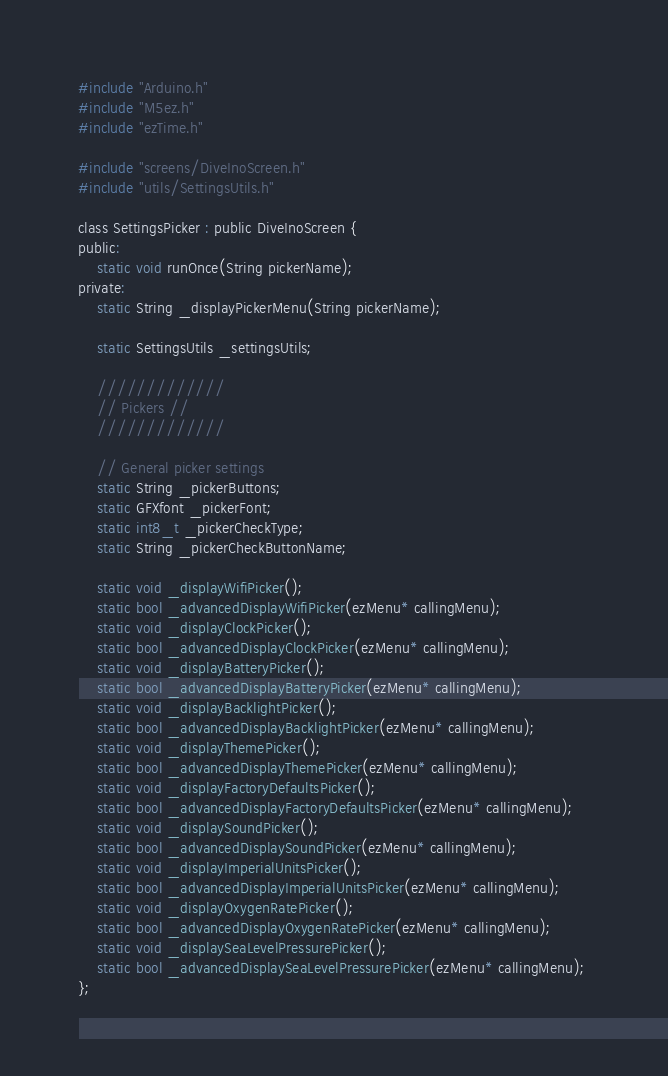<code> <loc_0><loc_0><loc_500><loc_500><_C_>#include "Arduino.h"
#include "M5ez.h"
#include "ezTime.h"

#include "screens/DiveInoScreen.h"
#include "utils/SettingsUtils.h"

class SettingsPicker : public DiveInoScreen {
public:    
    static void runOnce(String pickerName);        
private:
    static String _displayPickerMenu(String pickerName);

    static SettingsUtils _settingsUtils;

    /////////////
    // Pickers //
    /////////////

    // General picker settings
    static String _pickerButtons;
    static GFXfont _pickerFont;
    static int8_t _pickerCheckType;
    static String _pickerCheckButtonName;

    static void _displayWifiPicker();
    static bool _advancedDisplayWifiPicker(ezMenu* callingMenu);    
    static void _displayClockPicker();
    static bool _advancedDisplayClockPicker(ezMenu* callingMenu);
    static void _displayBatteryPicker();
    static bool _advancedDisplayBatteryPicker(ezMenu* callingMenu);    
    static void _displayBacklightPicker();
    static bool _advancedDisplayBacklightPicker(ezMenu* callingMenu);
    static void _displayThemePicker();
    static bool _advancedDisplayThemePicker(ezMenu* callingMenu);
    static void _displayFactoryDefaultsPicker();
    static bool _advancedDisplayFactoryDefaultsPicker(ezMenu* callingMenu);
    static void _displaySoundPicker();
    static bool _advancedDisplaySoundPicker(ezMenu* callingMenu);
    static void _displayImperialUnitsPicker();
    static bool _advancedDisplayImperialUnitsPicker(ezMenu* callingMenu);
    static void _displayOxygenRatePicker();
    static bool _advancedDisplayOxygenRatePicker(ezMenu* callingMenu);    
    static void _displaySeaLevelPressurePicker();
    static bool _advancedDisplaySeaLevelPressurePicker(ezMenu* callingMenu); 
};</code> 